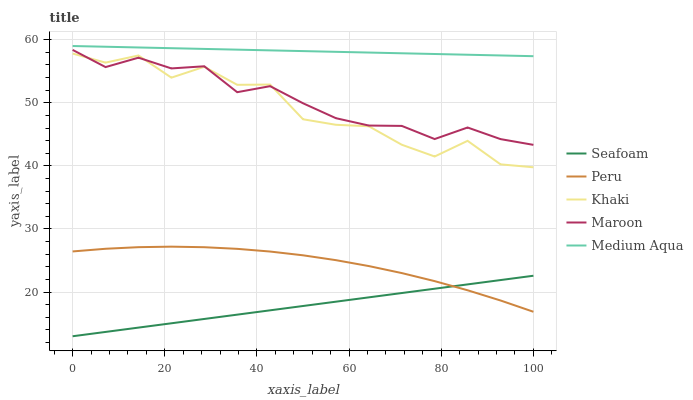Does Seafoam have the minimum area under the curve?
Answer yes or no. Yes. Does Medium Aqua have the maximum area under the curve?
Answer yes or no. Yes. Does Khaki have the minimum area under the curve?
Answer yes or no. No. Does Khaki have the maximum area under the curve?
Answer yes or no. No. Is Medium Aqua the smoothest?
Answer yes or no. Yes. Is Khaki the roughest?
Answer yes or no. Yes. Is Khaki the smoothest?
Answer yes or no. No. Is Medium Aqua the roughest?
Answer yes or no. No. Does Seafoam have the lowest value?
Answer yes or no. Yes. Does Khaki have the lowest value?
Answer yes or no. No. Does Medium Aqua have the highest value?
Answer yes or no. Yes. Does Khaki have the highest value?
Answer yes or no. No. Is Peru less than Maroon?
Answer yes or no. Yes. Is Khaki greater than Seafoam?
Answer yes or no. Yes. Does Peru intersect Seafoam?
Answer yes or no. Yes. Is Peru less than Seafoam?
Answer yes or no. No. Is Peru greater than Seafoam?
Answer yes or no. No. Does Peru intersect Maroon?
Answer yes or no. No. 